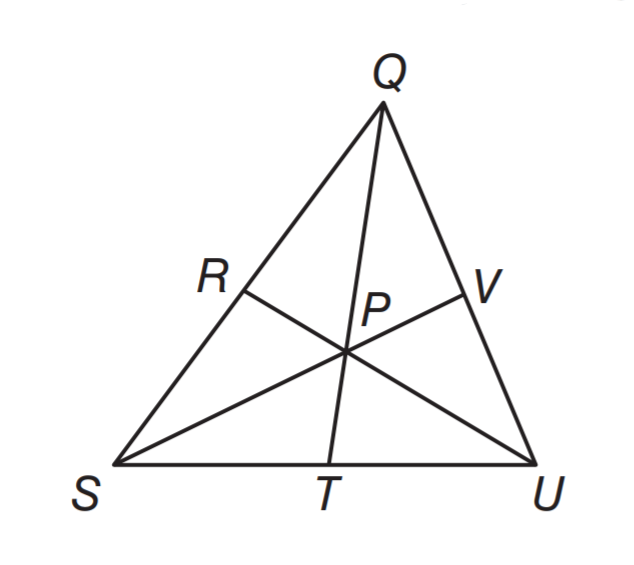Question: P is the centroid of triangle Q U S. If Q P = 14 centimeters, what is the length of Q T?
Choices:
A. 7
B. 12
C. 18
D. 21
Answer with the letter. Answer: D 